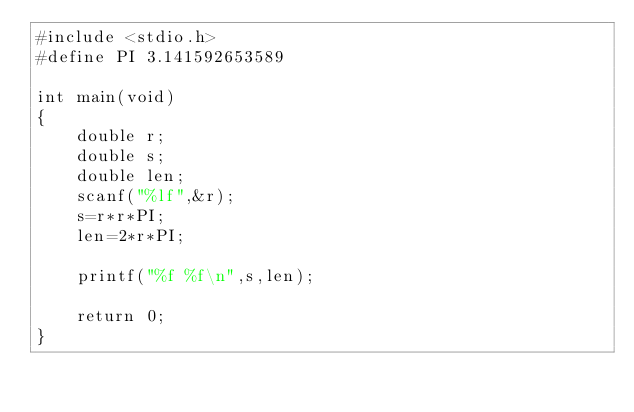Convert code to text. <code><loc_0><loc_0><loc_500><loc_500><_C_>#include <stdio.h>
#define PI 3.141592653589

int main(void)
{
	double r;
	double s;
	double len;
	scanf("%lf",&r);
	s=r*r*PI;
	len=2*r*PI;
	
	printf("%f %f\n",s,len);
	
	return 0;
}</code> 